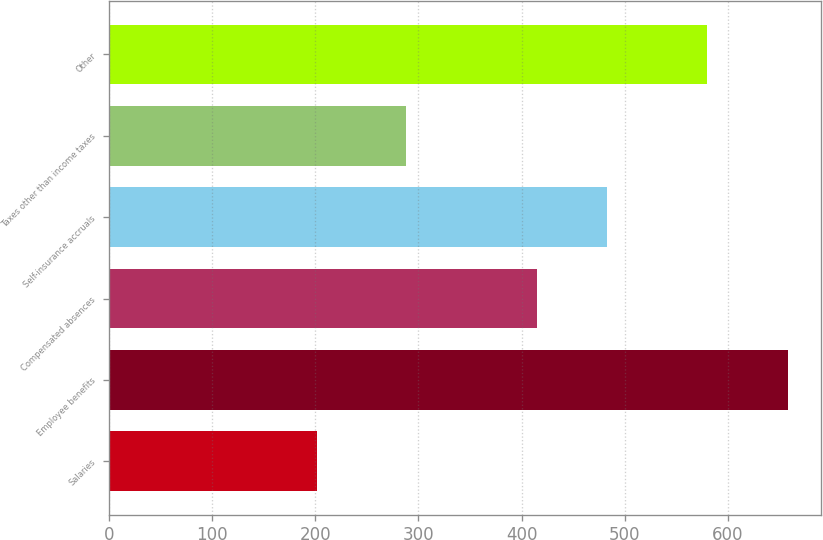Convert chart to OTSL. <chart><loc_0><loc_0><loc_500><loc_500><bar_chart><fcel>Salaries<fcel>Employee benefits<fcel>Compensated absences<fcel>Self-insurance accruals<fcel>Taxes other than income taxes<fcel>Other<nl><fcel>202<fcel>658<fcel>415<fcel>483<fcel>288<fcel>580<nl></chart> 